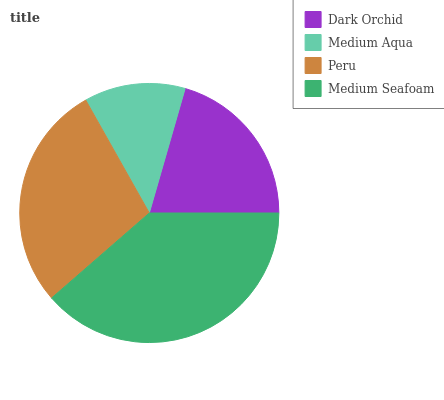Is Medium Aqua the minimum?
Answer yes or no. Yes. Is Medium Seafoam the maximum?
Answer yes or no. Yes. Is Peru the minimum?
Answer yes or no. No. Is Peru the maximum?
Answer yes or no. No. Is Peru greater than Medium Aqua?
Answer yes or no. Yes. Is Medium Aqua less than Peru?
Answer yes or no. Yes. Is Medium Aqua greater than Peru?
Answer yes or no. No. Is Peru less than Medium Aqua?
Answer yes or no. No. Is Peru the high median?
Answer yes or no. Yes. Is Dark Orchid the low median?
Answer yes or no. Yes. Is Dark Orchid the high median?
Answer yes or no. No. Is Medium Aqua the low median?
Answer yes or no. No. 